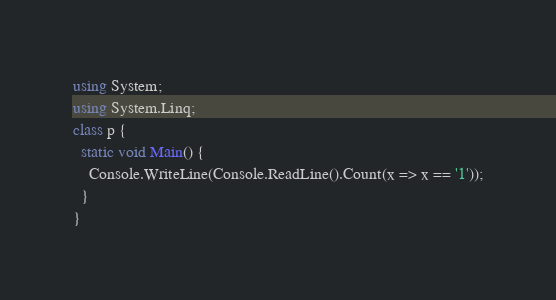<code> <loc_0><loc_0><loc_500><loc_500><_C#_>using System;
using System.Linq;
class p {
  static void Main() {
    Console.WriteLine(Console.ReadLine().Count(x => x == '1'));
  }
}</code> 